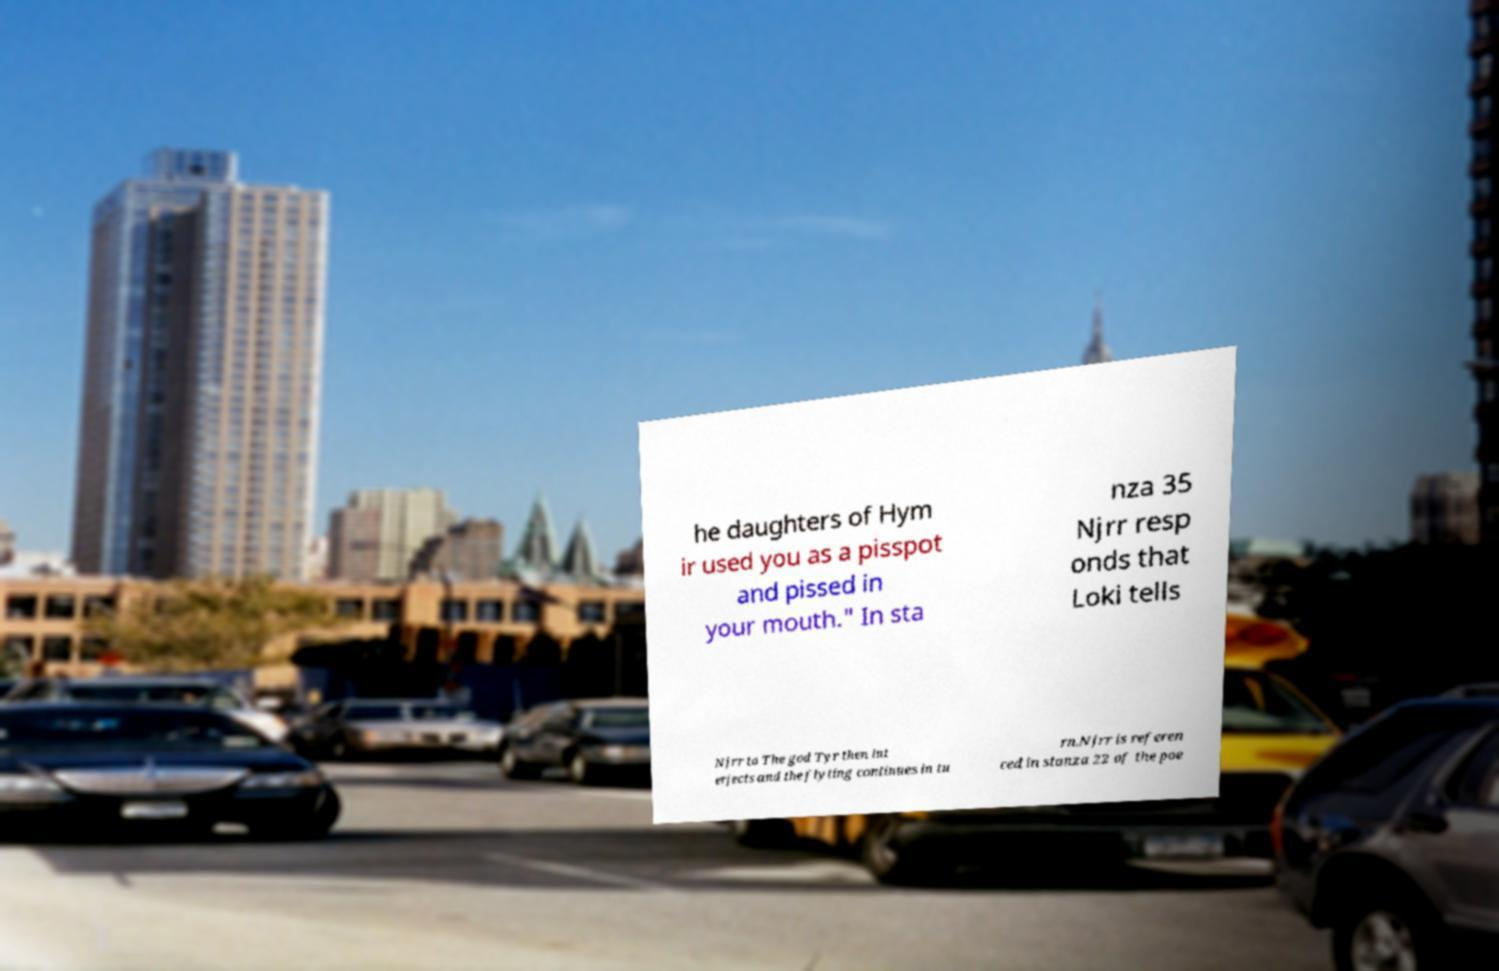Could you extract and type out the text from this image? he daughters of Hym ir used you as a pisspot and pissed in your mouth." In sta nza 35 Njrr resp onds that Loki tells Njrr to The god Tyr then int erjects and the flyting continues in tu rn.Njrr is referen ced in stanza 22 of the poe 